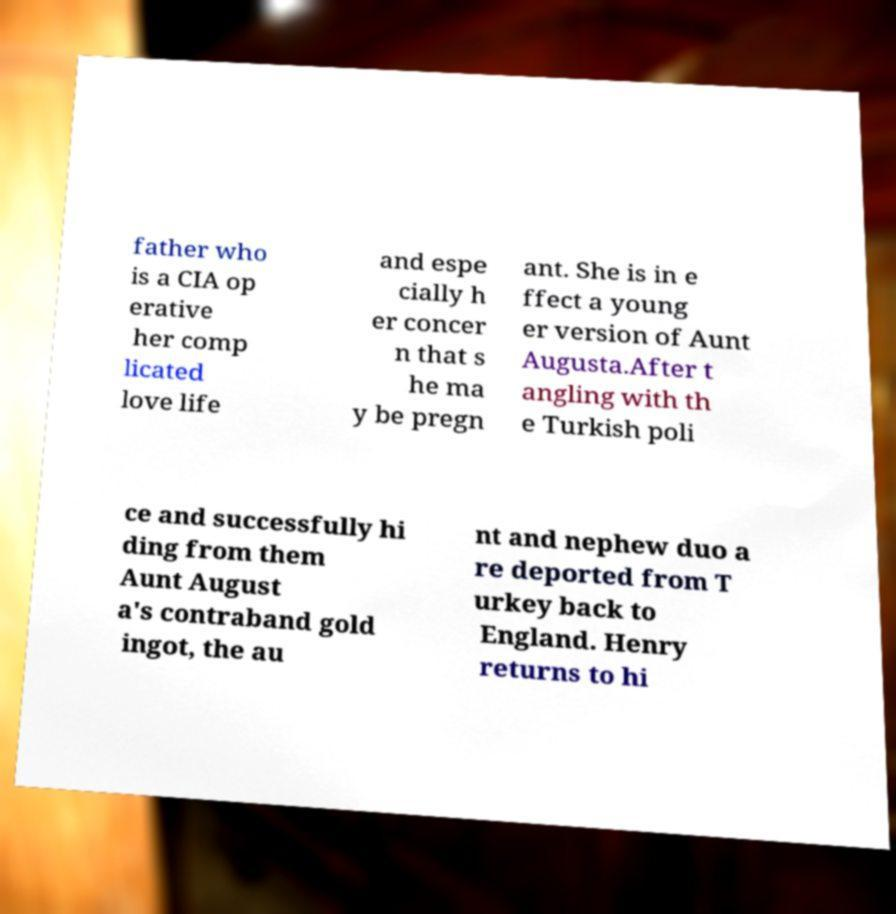Please read and relay the text visible in this image. What does it say? father who is a CIA op erative her comp licated love life and espe cially h er concer n that s he ma y be pregn ant. She is in e ffect a young er version of Aunt Augusta.After t angling with th e Turkish poli ce and successfully hi ding from them Aunt August a's contraband gold ingot, the au nt and nephew duo a re deported from T urkey back to England. Henry returns to hi 